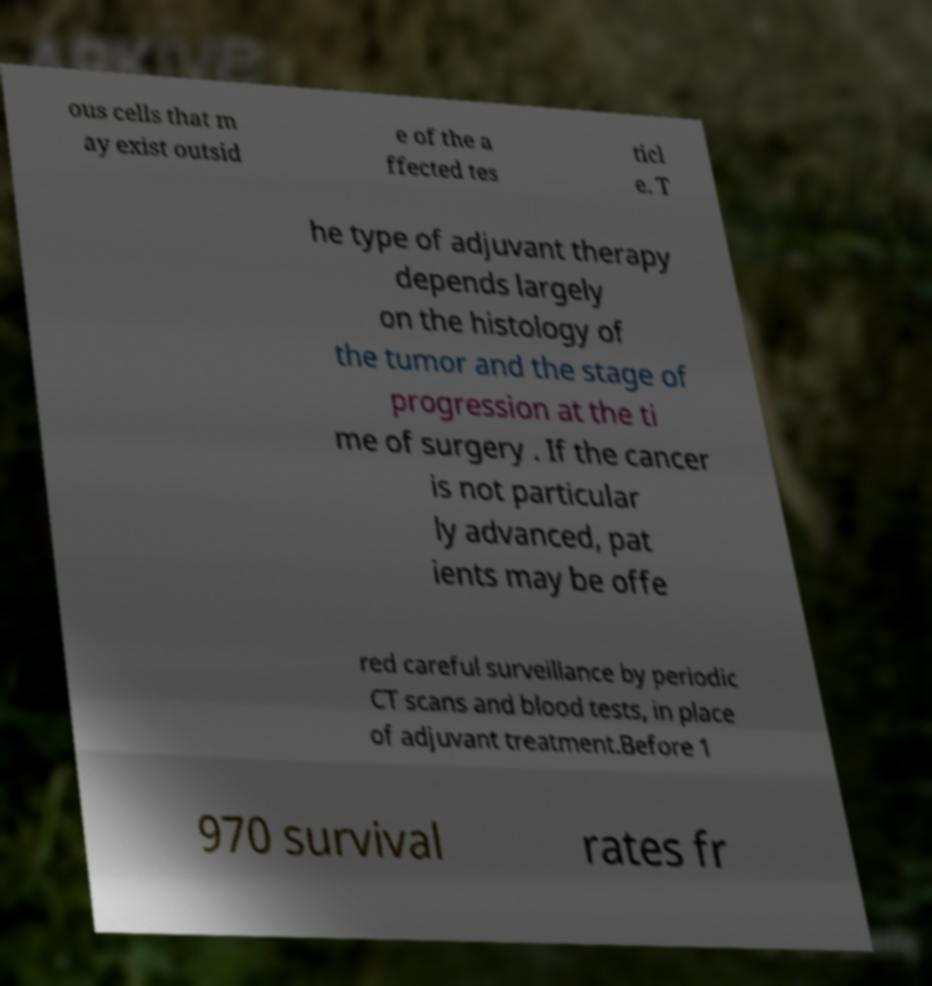There's text embedded in this image that I need extracted. Can you transcribe it verbatim? ous cells that m ay exist outsid e of the a ffected tes ticl e. T he type of adjuvant therapy depends largely on the histology of the tumor and the stage of progression at the ti me of surgery . If the cancer is not particular ly advanced, pat ients may be offe red careful surveillance by periodic CT scans and blood tests, in place of adjuvant treatment.Before 1 970 survival rates fr 